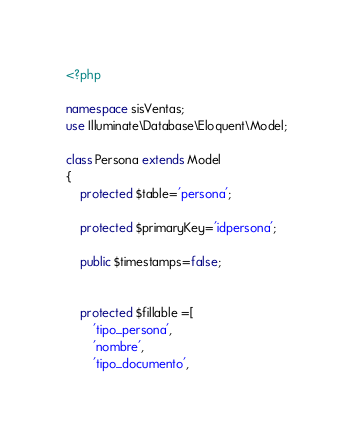Convert code to text. <code><loc_0><loc_0><loc_500><loc_500><_PHP_><?php

namespace sisVentas;
use Illuminate\Database\Eloquent\Model;

class Persona extends Model
{
    protected $table='persona';

    protected $primaryKey='idpersona';

    public $timestamps=false;


    protected $fillable =[
    	'tipo_persona',
    	'nombre',
    	'tipo_documento',</code> 